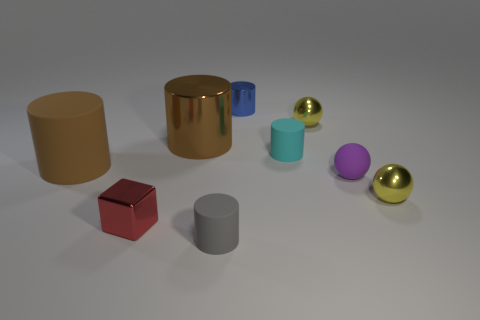Subtract all blue cylinders. How many cylinders are left? 4 Subtract all purple spheres. How many spheres are left? 2 Subtract 1 cylinders. How many cylinders are left? 4 Subtract all purple spheres. How many blue cylinders are left? 1 Subtract all big metal objects. Subtract all tiny matte balls. How many objects are left? 7 Add 6 big brown metallic things. How many big brown metallic things are left? 7 Add 6 small gray cylinders. How many small gray cylinders exist? 7 Subtract 0 cyan cubes. How many objects are left? 9 Subtract all cylinders. How many objects are left? 4 Subtract all purple cylinders. Subtract all gray cubes. How many cylinders are left? 5 